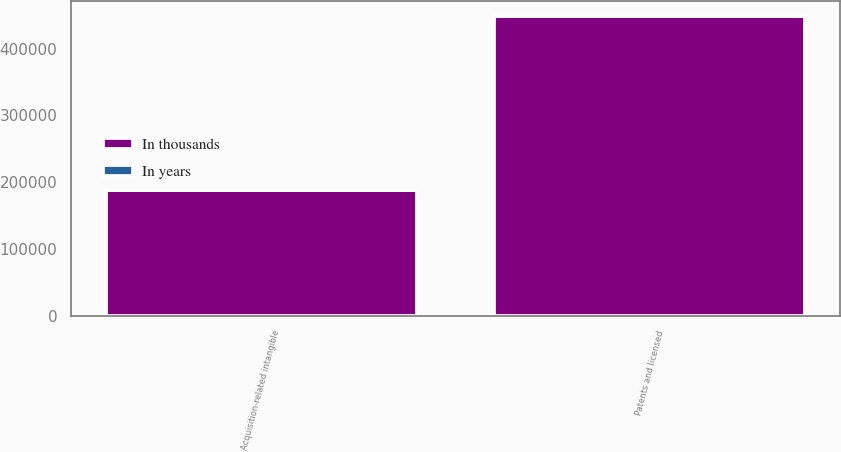Convert chart. <chart><loc_0><loc_0><loc_500><loc_500><stacked_bar_chart><ecel><fcel>Acquisition-related intangible<fcel>Patents and licensed<nl><fcel>In thousands<fcel>189239<fcel>448873<nl><fcel>In years<fcel>6.8<fcel>7.2<nl></chart> 